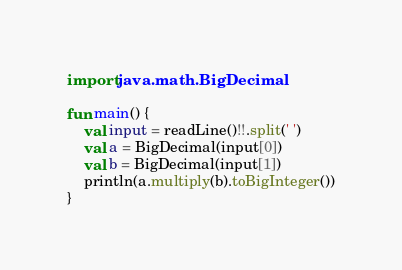<code> <loc_0><loc_0><loc_500><loc_500><_Kotlin_>import java.math.BigDecimal

fun main() {
    val input = readLine()!!.split(' ')
    val a = BigDecimal(input[0])
    val b = BigDecimal(input[1])
    println(a.multiply(b).toBigInteger())
}</code> 